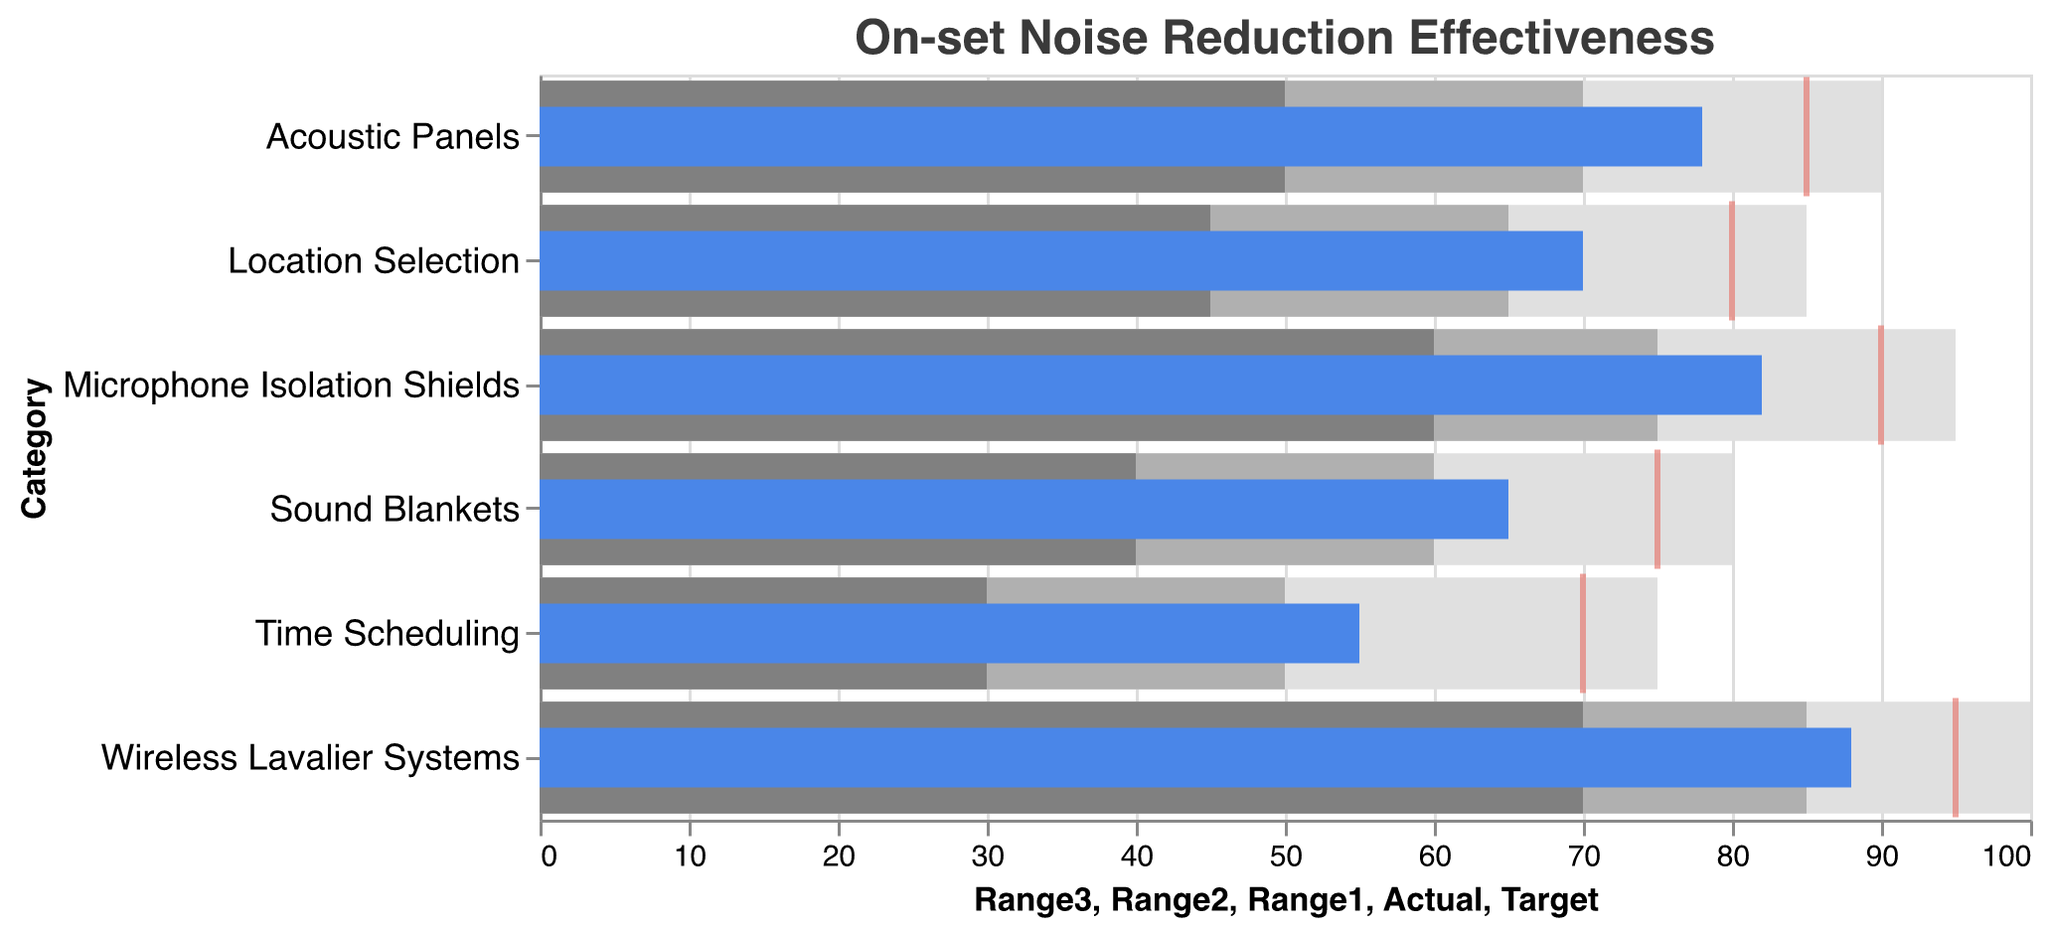What is the target value for Acoustic Panels? The target value is indicated by a tick mark on the bar representing Acoustic Panels.
Answer: 85 What category has the lowest actual noise reduction effectiveness? By locating each category's actual value, Time Scheduling has the lowest actual value of 55.
Answer: Time Scheduling Which technique exceeds its target noise reduction effectiveness? Compare the actual values with their corresponding target values. Wireless Lavalier Systems (88 > 95) falls closest, but none exceed the target.
Answer: None What is the actual noise reduction value for Microphone Isolation Shields? The actual value for Microphone Isolation Shields is shown at the blue bar for this category.
Answer: 82 How many categories have an actual value higher than 70? Count the categories with actual values greater than 70: Acoustic Panels (78), Microphone Isolation Shields (82), and Wireless Lavalier Systems (88). There are 3.
Answer: 3 Which category falls in the first range (Range1) for its actual effectiveness? Compare the actual values with Range1. For Time Scheduling (Actual: 55, Range1: 30-50), the actual falls within Range1.
Answer: Time Scheduling What is the difference between the actual and target values for Sound Blankets? The actual value is 65; the target is 75. The difference is 75 - 65 = 10.
Answer: 10 Which technique has the highest target noise reduction effectiveness? The highest target value is identified by comparing all target values. Wireless Lavalier Systems has the highest target value of 95.
Answer: Wireless Lavalier Systems How does the actual noise reduction of Location Selection compare to its target? The actual value for Location Selection is 70 and the target is 80. Location Selection's actual value is 10 less than its target (80 - 70 = 10).
Answer: 10 less What is the average target value across all techniques? Sum all target values and divide by the number of categories. (85 + 75 + 90 + 70 + 80 + 95) / 6 = 82.5.
Answer: 82.5 